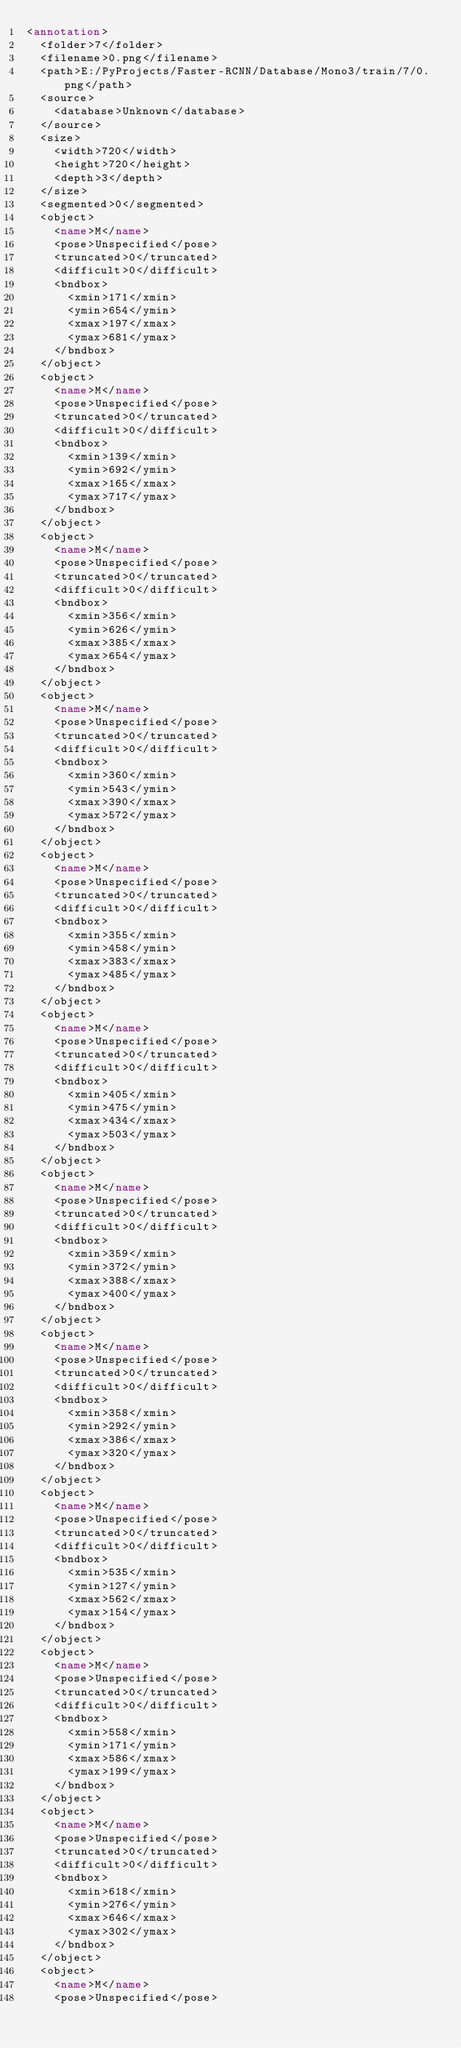<code> <loc_0><loc_0><loc_500><loc_500><_XML_><annotation>
	<folder>7</folder>
	<filename>0.png</filename>
	<path>E:/PyProjects/Faster-RCNN/Database/Mono3/train/7/0.png</path>
	<source>
		<database>Unknown</database>
	</source>
	<size>
		<width>720</width>
		<height>720</height>
		<depth>3</depth>
	</size>
	<segmented>0</segmented>
	<object>
		<name>M</name>
		<pose>Unspecified</pose>
		<truncated>0</truncated>
		<difficult>0</difficult>
		<bndbox>
			<xmin>171</xmin>
			<ymin>654</ymin>
			<xmax>197</xmax>
			<ymax>681</ymax>
		</bndbox>
	</object>
	<object>
		<name>M</name>
		<pose>Unspecified</pose>
		<truncated>0</truncated>
		<difficult>0</difficult>
		<bndbox>
			<xmin>139</xmin>
			<ymin>692</ymin>
			<xmax>165</xmax>
			<ymax>717</ymax>
		</bndbox>
	</object>
	<object>
		<name>M</name>
		<pose>Unspecified</pose>
		<truncated>0</truncated>
		<difficult>0</difficult>
		<bndbox>
			<xmin>356</xmin>
			<ymin>626</ymin>
			<xmax>385</xmax>
			<ymax>654</ymax>
		</bndbox>
	</object>
	<object>
		<name>M</name>
		<pose>Unspecified</pose>
		<truncated>0</truncated>
		<difficult>0</difficult>
		<bndbox>
			<xmin>360</xmin>
			<ymin>543</ymin>
			<xmax>390</xmax>
			<ymax>572</ymax>
		</bndbox>
	</object>
	<object>
		<name>M</name>
		<pose>Unspecified</pose>
		<truncated>0</truncated>
		<difficult>0</difficult>
		<bndbox>
			<xmin>355</xmin>
			<ymin>458</ymin>
			<xmax>383</xmax>
			<ymax>485</ymax>
		</bndbox>
	</object>
	<object>
		<name>M</name>
		<pose>Unspecified</pose>
		<truncated>0</truncated>
		<difficult>0</difficult>
		<bndbox>
			<xmin>405</xmin>
			<ymin>475</ymin>
			<xmax>434</xmax>
			<ymax>503</ymax>
		</bndbox>
	</object>
	<object>
		<name>M</name>
		<pose>Unspecified</pose>
		<truncated>0</truncated>
		<difficult>0</difficult>
		<bndbox>
			<xmin>359</xmin>
			<ymin>372</ymin>
			<xmax>388</xmax>
			<ymax>400</ymax>
		</bndbox>
	</object>
	<object>
		<name>M</name>
		<pose>Unspecified</pose>
		<truncated>0</truncated>
		<difficult>0</difficult>
		<bndbox>
			<xmin>358</xmin>
			<ymin>292</ymin>
			<xmax>386</xmax>
			<ymax>320</ymax>
		</bndbox>
	</object>
	<object>
		<name>M</name>
		<pose>Unspecified</pose>
		<truncated>0</truncated>
		<difficult>0</difficult>
		<bndbox>
			<xmin>535</xmin>
			<ymin>127</ymin>
			<xmax>562</xmax>
			<ymax>154</ymax>
		</bndbox>
	</object>
	<object>
		<name>M</name>
		<pose>Unspecified</pose>
		<truncated>0</truncated>
		<difficult>0</difficult>
		<bndbox>
			<xmin>558</xmin>
			<ymin>171</ymin>
			<xmax>586</xmax>
			<ymax>199</ymax>
		</bndbox>
	</object>
	<object>
		<name>M</name>
		<pose>Unspecified</pose>
		<truncated>0</truncated>
		<difficult>0</difficult>
		<bndbox>
			<xmin>618</xmin>
			<ymin>276</ymin>
			<xmax>646</xmax>
			<ymax>302</ymax>
		</bndbox>
	</object>
	<object>
		<name>M</name>
		<pose>Unspecified</pose></code> 